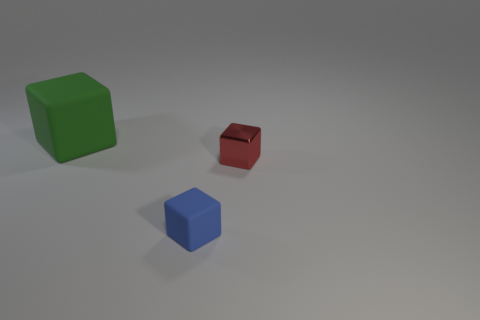The tiny thing that is to the left of the thing right of the blue block is made of what material?
Your response must be concise. Rubber. How many things are either blue matte objects or tiny blue rubber spheres?
Offer a terse response. 1. Is the number of rubber things less than the number of tiny purple shiny balls?
Make the answer very short. No. There is another block that is made of the same material as the blue cube; what size is it?
Offer a terse response. Large. How big is the green thing?
Offer a terse response. Large. What is the shape of the tiny blue rubber thing?
Offer a very short reply. Cube. Is the color of the block that is behind the tiny metal object the same as the shiny thing?
Your answer should be compact. No. The other shiny object that is the same shape as the blue thing is what size?
Provide a short and direct response. Small. Is there any other thing that has the same material as the blue block?
Your answer should be compact. Yes. There is a small cube in front of the tiny cube that is on the right side of the small blue rubber cube; is there a rubber cube that is in front of it?
Make the answer very short. No. 